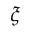<formula> <loc_0><loc_0><loc_500><loc_500>\xi</formula> 